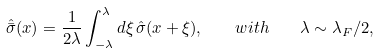Convert formula to latex. <formula><loc_0><loc_0><loc_500><loc_500>\hat { \bar { \sigma } } ( x ) = \frac { 1 } { 2 \lambda } \int _ { - \lambda } ^ { \lambda } d \xi \, \hat { \sigma } ( x + \xi ) , \quad w i t h \quad \lambda \sim \lambda _ { F } / 2 ,</formula> 